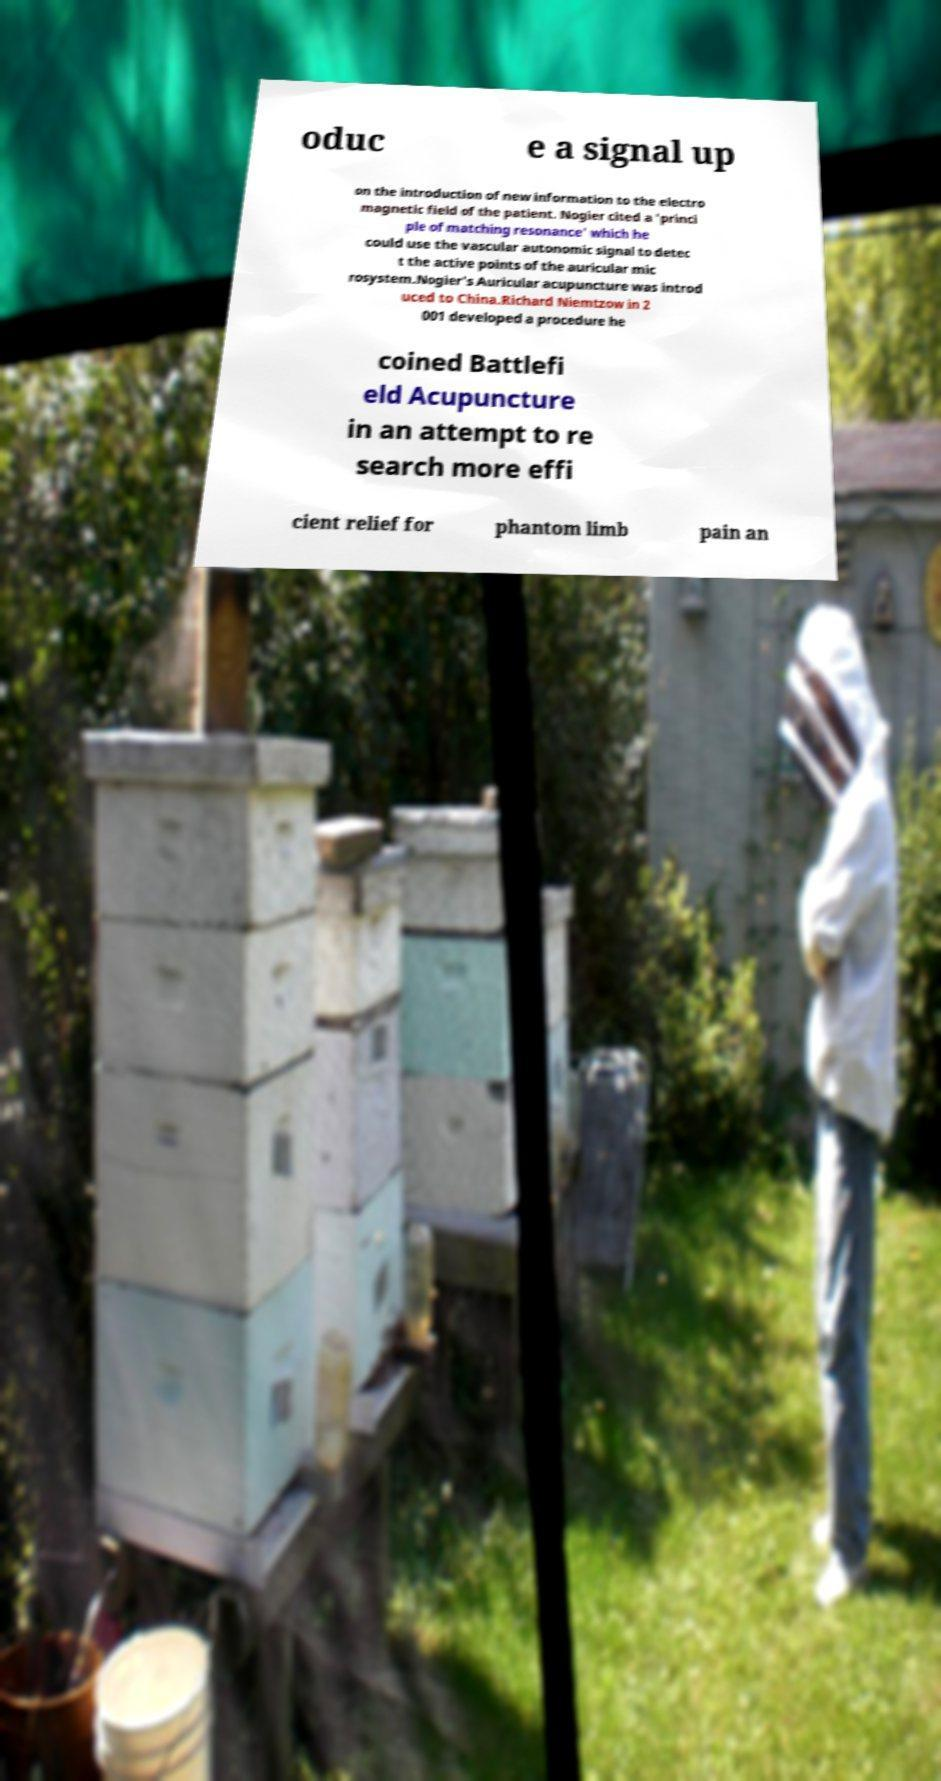For documentation purposes, I need the text within this image transcribed. Could you provide that? oduc e a signal up on the introduction of new information to the electro magnetic field of the patient. Nogier cited a 'princi ple of matching resonance' which he could use the vascular autonomic signal to detec t the active points of the auricular mic rosystem.Nogier's Auricular acupuncture was introd uced to China.Richard Niemtzow in 2 001 developed a procedure he coined Battlefi eld Acupuncture in an attempt to re search more effi cient relief for phantom limb pain an 